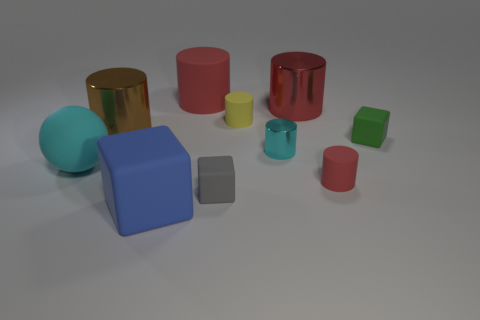Subtract all red cylinders. How many were subtracted if there are2red cylinders left? 1 Subtract all cyan blocks. How many red cylinders are left? 3 Subtract all big blue cubes. How many cubes are left? 2 Subtract all spheres. How many objects are left? 9 Subtract all red cylinders. How many cylinders are left? 3 Subtract all cyan cubes. Subtract all purple cylinders. How many cubes are left? 3 Subtract all tiny gray matte blocks. Subtract all tiny matte cylinders. How many objects are left? 7 Add 5 big rubber cylinders. How many big rubber cylinders are left? 6 Add 1 rubber balls. How many rubber balls exist? 2 Subtract 1 brown cylinders. How many objects are left? 9 